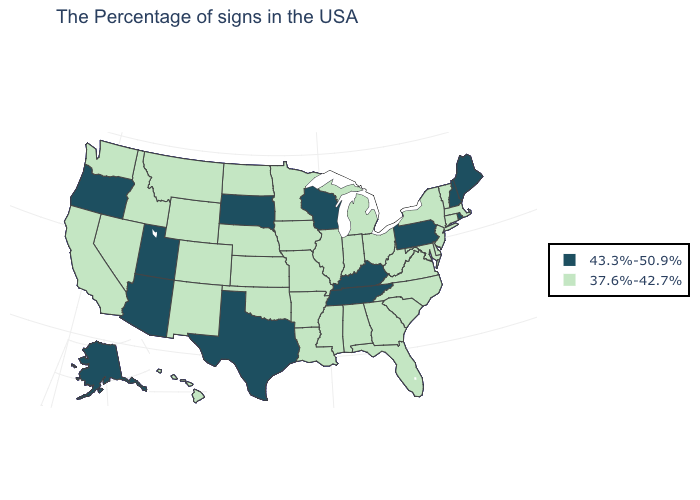Which states have the lowest value in the South?
Write a very short answer. Delaware, Maryland, Virginia, North Carolina, South Carolina, West Virginia, Florida, Georgia, Alabama, Mississippi, Louisiana, Arkansas, Oklahoma. What is the value of Rhode Island?
Keep it brief. 43.3%-50.9%. Among the states that border California , does Nevada have the lowest value?
Be succinct. Yes. Does Louisiana have the highest value in the USA?
Short answer required. No. What is the highest value in the USA?
Short answer required. 43.3%-50.9%. Name the states that have a value in the range 43.3%-50.9%?
Be succinct. Maine, Rhode Island, New Hampshire, Pennsylvania, Kentucky, Tennessee, Wisconsin, Texas, South Dakota, Utah, Arizona, Oregon, Alaska. Does the first symbol in the legend represent the smallest category?
Answer briefly. No. Which states have the highest value in the USA?
Quick response, please. Maine, Rhode Island, New Hampshire, Pennsylvania, Kentucky, Tennessee, Wisconsin, Texas, South Dakota, Utah, Arizona, Oregon, Alaska. Is the legend a continuous bar?
Concise answer only. No. What is the value of North Carolina?
Concise answer only. 37.6%-42.7%. Which states hav the highest value in the Northeast?
Give a very brief answer. Maine, Rhode Island, New Hampshire, Pennsylvania. Does North Carolina have the lowest value in the USA?
Keep it brief. Yes. Which states have the highest value in the USA?
Answer briefly. Maine, Rhode Island, New Hampshire, Pennsylvania, Kentucky, Tennessee, Wisconsin, Texas, South Dakota, Utah, Arizona, Oregon, Alaska. Name the states that have a value in the range 43.3%-50.9%?
Short answer required. Maine, Rhode Island, New Hampshire, Pennsylvania, Kentucky, Tennessee, Wisconsin, Texas, South Dakota, Utah, Arizona, Oregon, Alaska. Among the states that border South Dakota , which have the highest value?
Give a very brief answer. Minnesota, Iowa, Nebraska, North Dakota, Wyoming, Montana. 